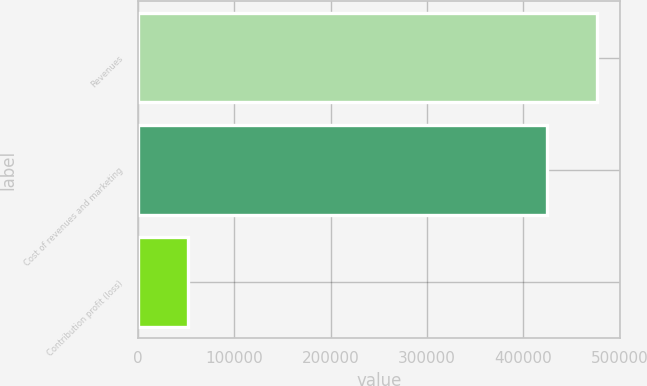Convert chart to OTSL. <chart><loc_0><loc_0><loc_500><loc_500><bar_chart><fcel>Revenues<fcel>Cost of revenues and marketing<fcel>Contribution profit (loss)<nl><fcel>476334<fcel>424224<fcel>52110<nl></chart> 